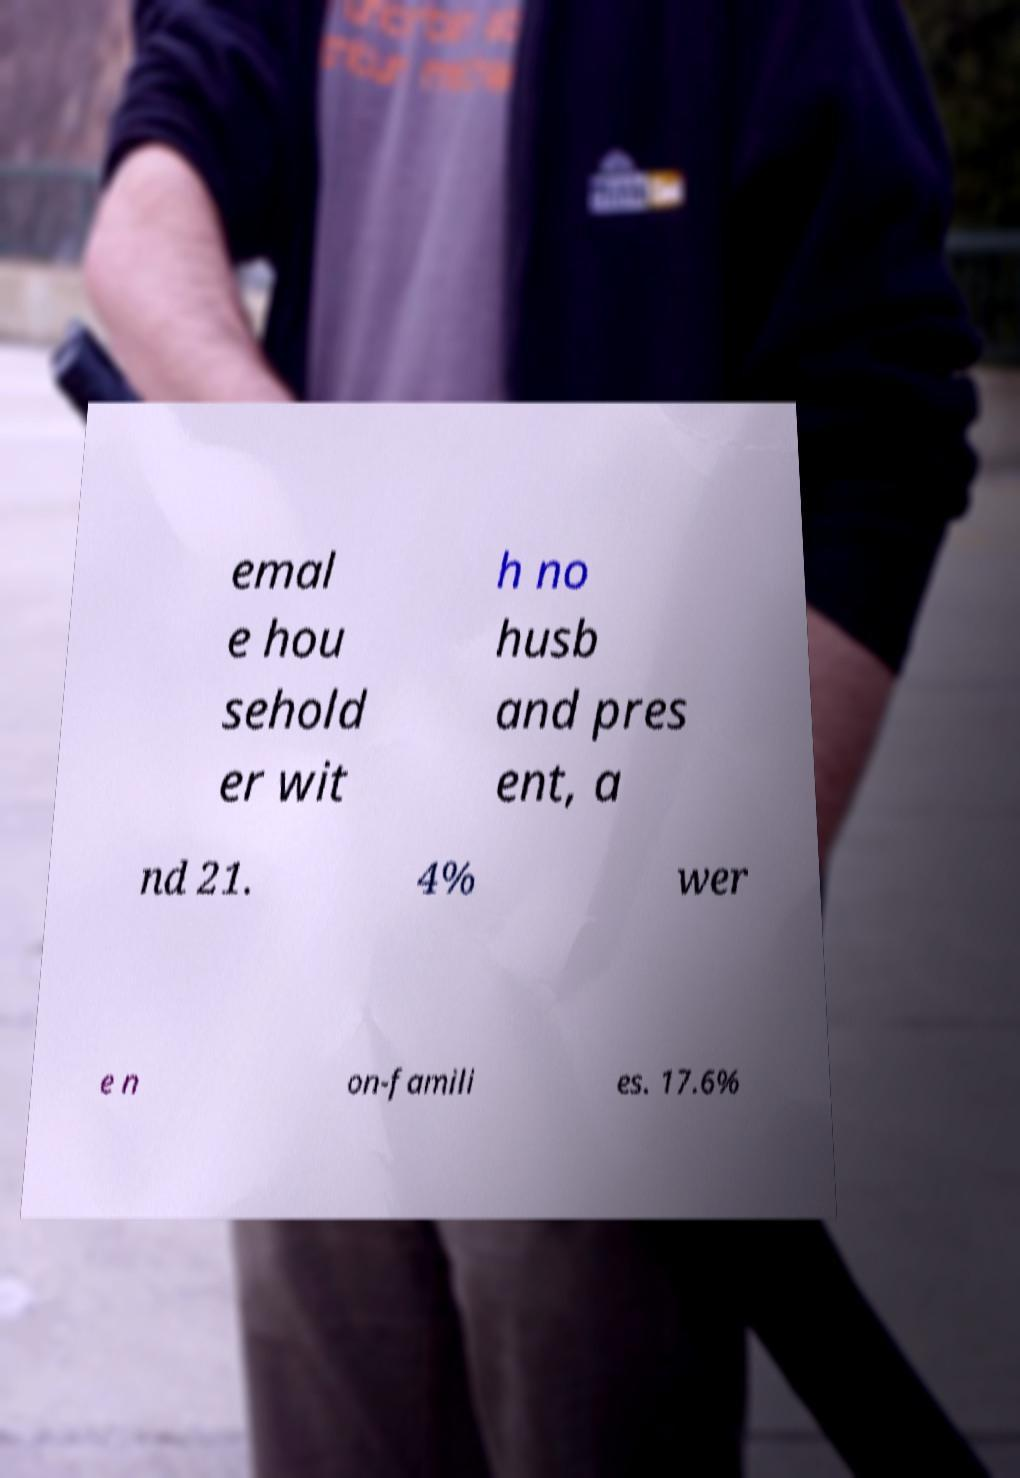What messages or text are displayed in this image? I need them in a readable, typed format. emal e hou sehold er wit h no husb and pres ent, a nd 21. 4% wer e n on-famili es. 17.6% 